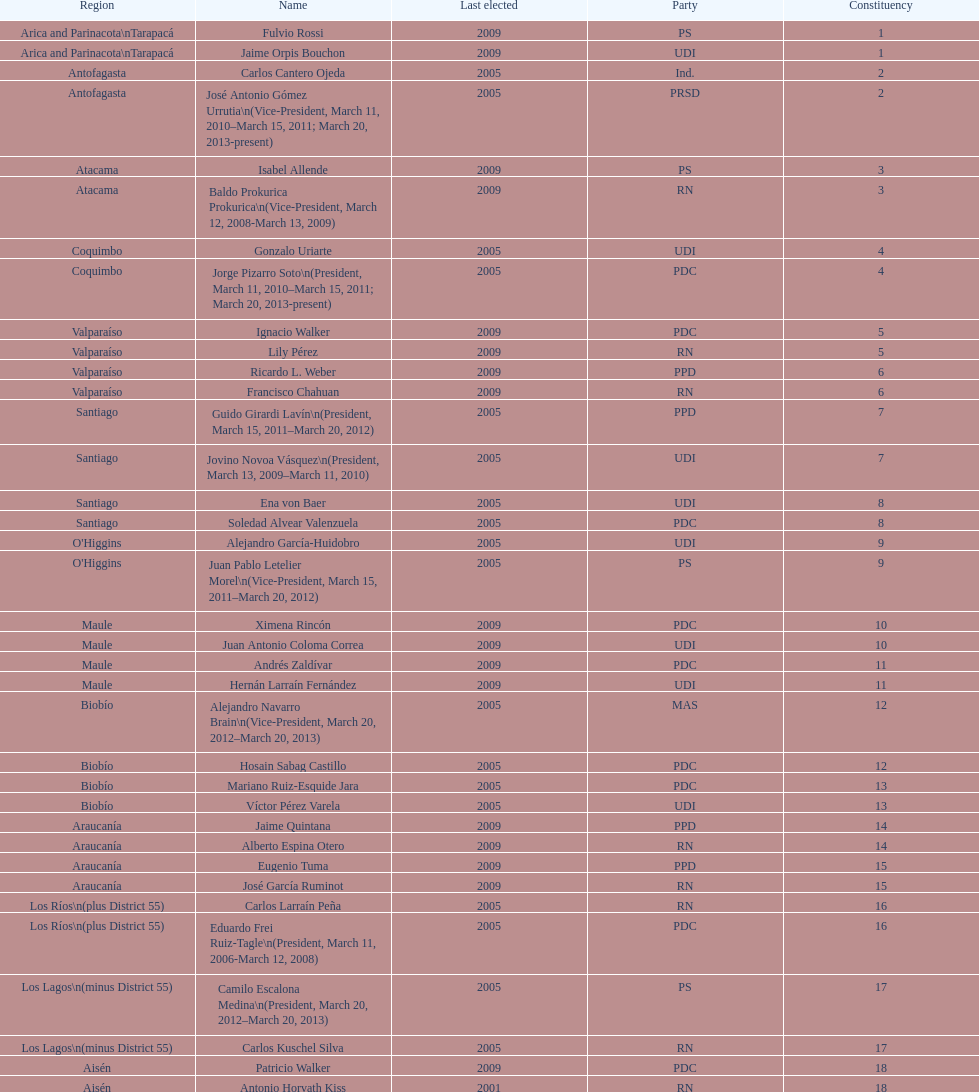What is the difference in years between constiuency 1 and 2? 4 years. 